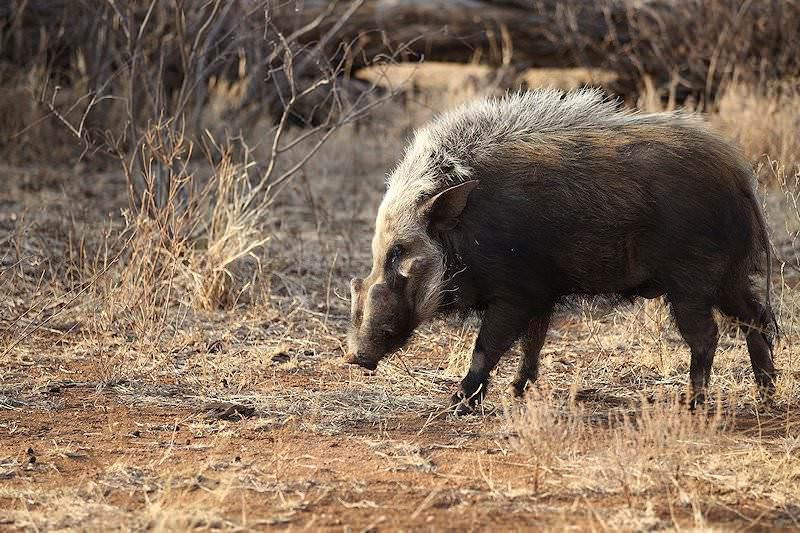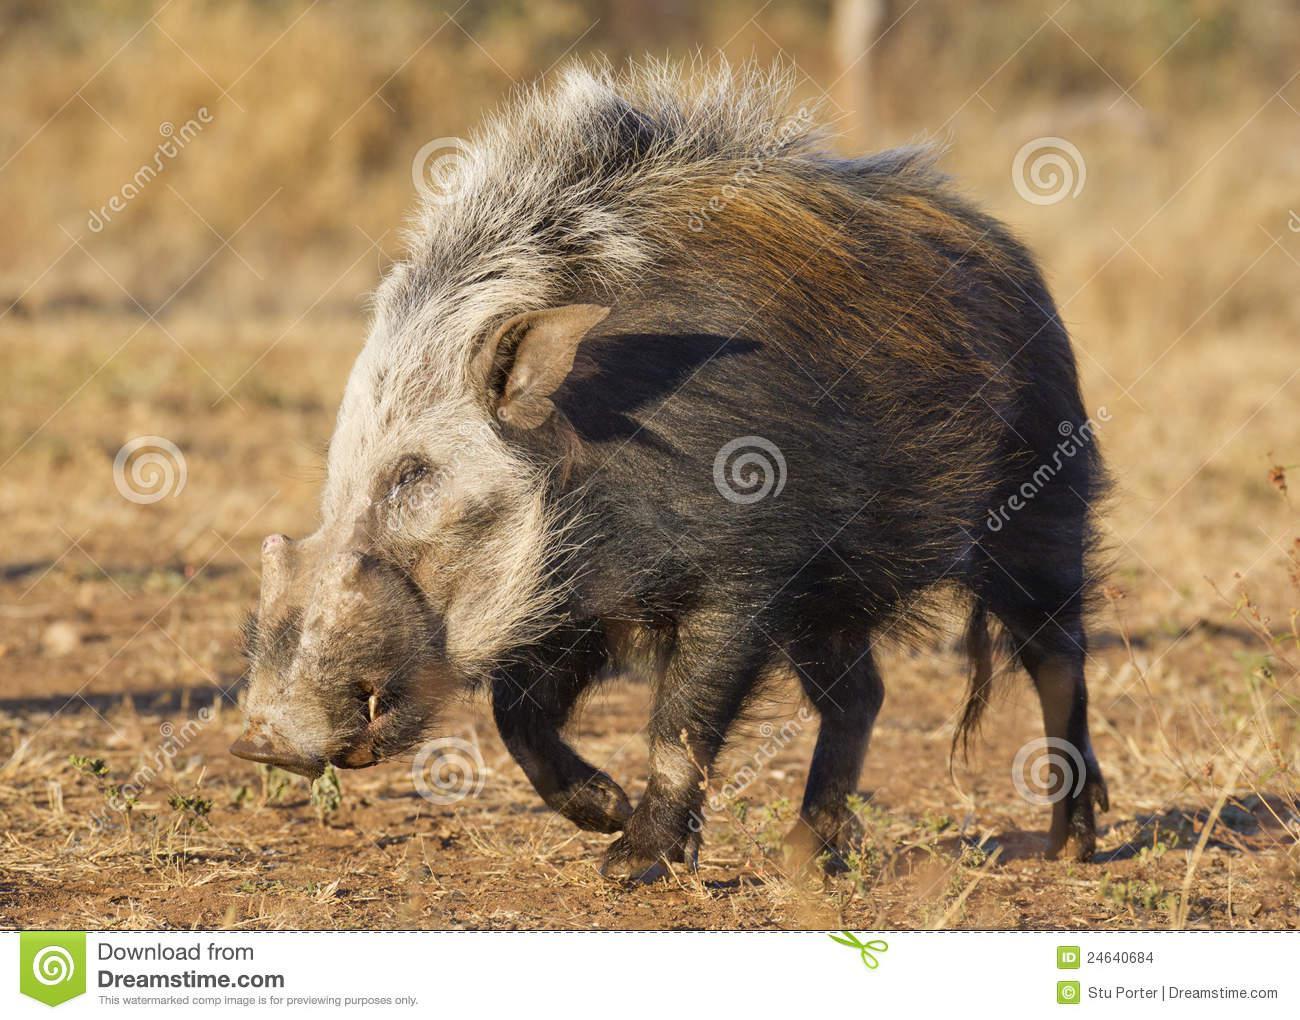The first image is the image on the left, the second image is the image on the right. Analyze the images presented: Is the assertion "All pigs shown in the images face the same direction." valid? Answer yes or no. Yes. The first image is the image on the left, the second image is the image on the right. Analyze the images presented: Is the assertion "There are two hogs in total." valid? Answer yes or no. Yes. 